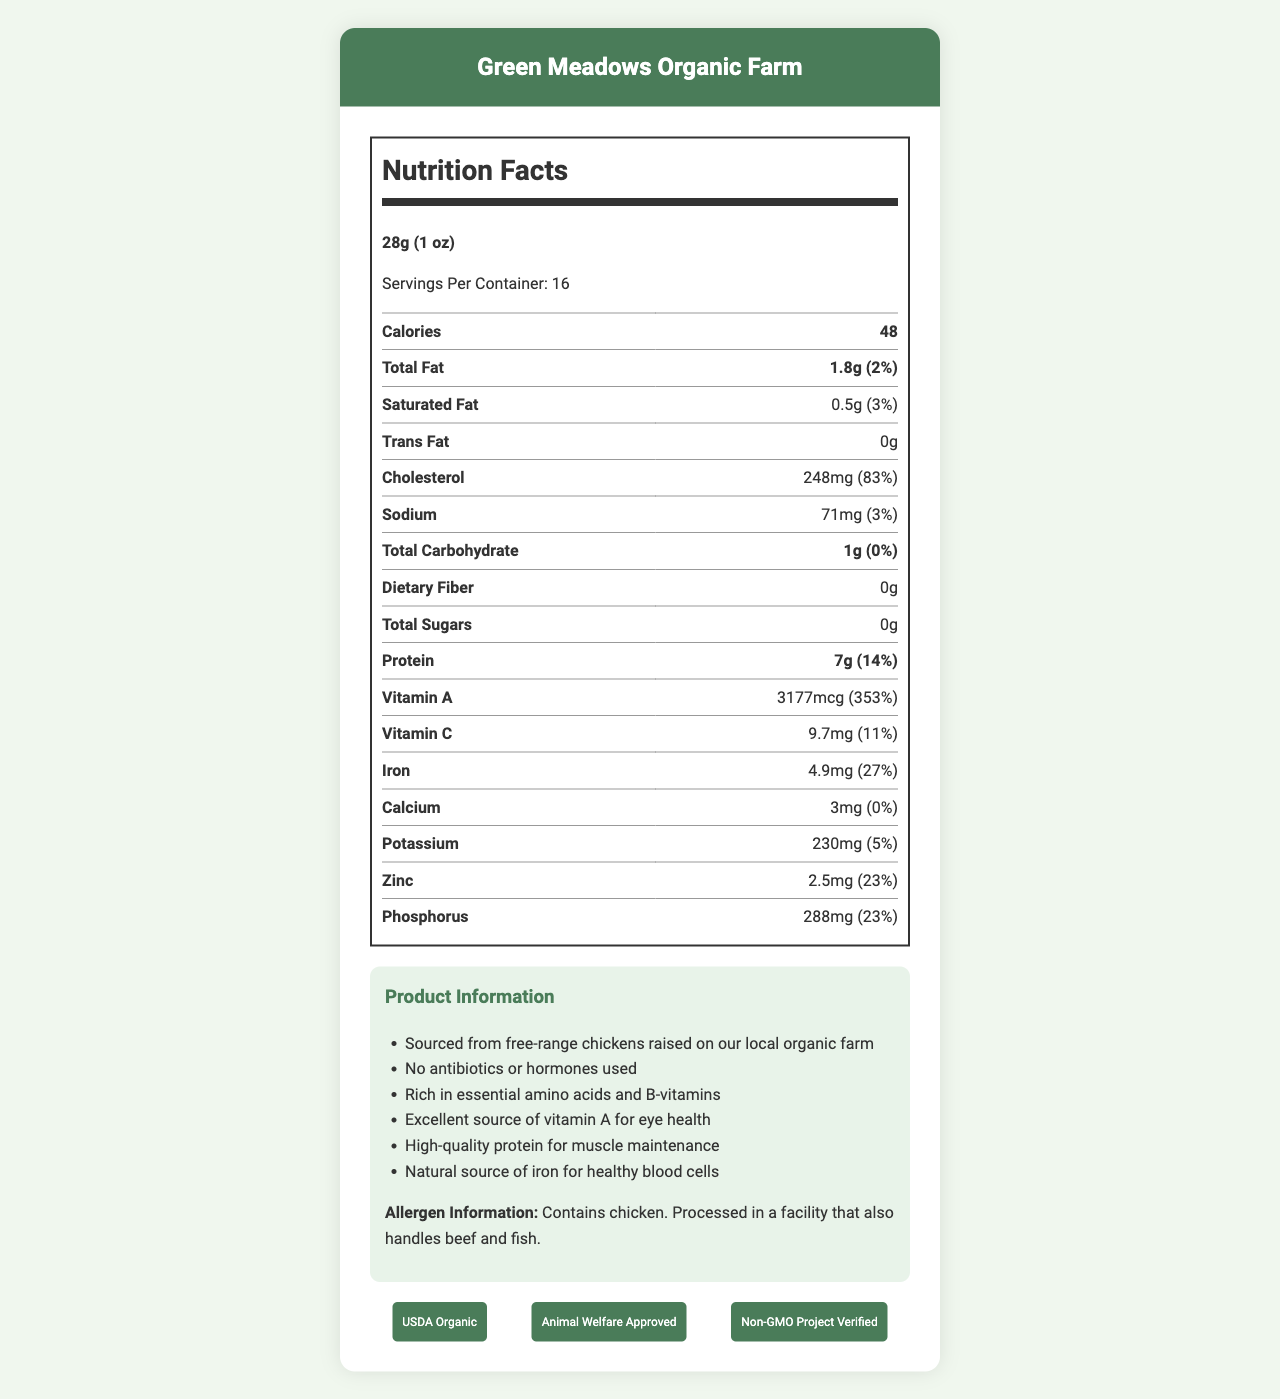what is the serving size of the product? The serving size is explicitly stated as "28g (1 oz)" in the document.
Answer: 28g (1 oz) how many servings are there per container? The document lists "Servings Per Container: 16".
Answer: 16 how much protein is in one serving? The protein content per serving is specified as "7g".
Answer: 7g what is the percentage daily value for vitamin A? The daily value percentage for vitamin A is directly provided as "353%".
Answer: 353% how much cholesterol is in one serving? The document indicates that there are "248mg" of cholesterol per serving.
Answer: 248mg which certification is not mentioned in the document? A. USDA Organic B. Animal Welfare Approved C. Non-GMO Project Verified D. Certified Humane The certifications mentioned in the document are "USDA Organic", "Animal Welfare Approved", and "Non-GMO Project Verified". "Certified Humane" is not listed.
Answer: D what is the source of the chickens for this product? The document specifies that the product is sourced from "free-range chickens raised on our local organic farm" and names the farm as "Green Meadows Organic Farm".
Answer: free-range chickens raised on Green Meadows Organic Farm how many calories are in one serving of the product? The document states that each serving contains "48 calories".
Answer: 48 what is the total carbohydrate content in one serving? A. 0g B. 1g C. 2g D. 3g The total carbohydrate content per serving is listed as "1g".
Answer: B is the product free of antibiotics and hormones? The document states, "No antibiotics or hormones used," indicating that the product is free of them.
Answer: Yes does the product contain beef? The allergen information specifies that the product contains chicken and is processed in a facility that also handles beef and fish. The product itself does not contain beef.
Answer: No what percentage of the daily value for iron does one serving provide? The document lists the daily value percentage for iron as "27%".
Answer: 27% summarize the main idea of the document. The document presents key nutritional details and highlights the natural sourcing of the product, emphasizing its health benefits and certifications.
Answer: The document provides detailed nutrition facts and product information for "Organic Chicken Liver for Pets" sourced from Green Meadows Organic Farm. It outlines the serving size, servings per container, calories, and various nutrient contents, including protein and vitamin A. The document also highlights the product's sourcing, absence of antibiotics and hormones, and various certifications. what is the cost per serving of the product? The document does not provide any information regarding the cost of the product.
Answer: Cannot be determined 